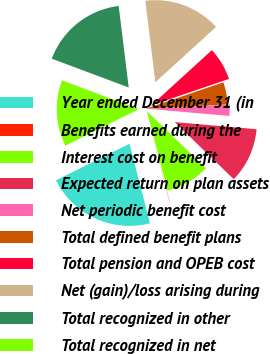Convert chart to OTSL. <chart><loc_0><loc_0><loc_500><loc_500><pie_chart><fcel>Year ended December 31 (in<fcel>Benefits earned during the<fcel>Interest cost on benefit<fcel>Expected return on plan assets<fcel>Net periodic benefit cost<fcel>Total defined benefit plans<fcel>Total pension and OPEB cost<fcel>Net (gain)/loss arising during<fcel>Total recognized in other<fcel>Total recognized in net<nl><fcel>21.68%<fcel>0.05%<fcel>8.7%<fcel>10.86%<fcel>2.22%<fcel>4.38%<fcel>6.54%<fcel>15.19%<fcel>17.35%<fcel>13.03%<nl></chart> 